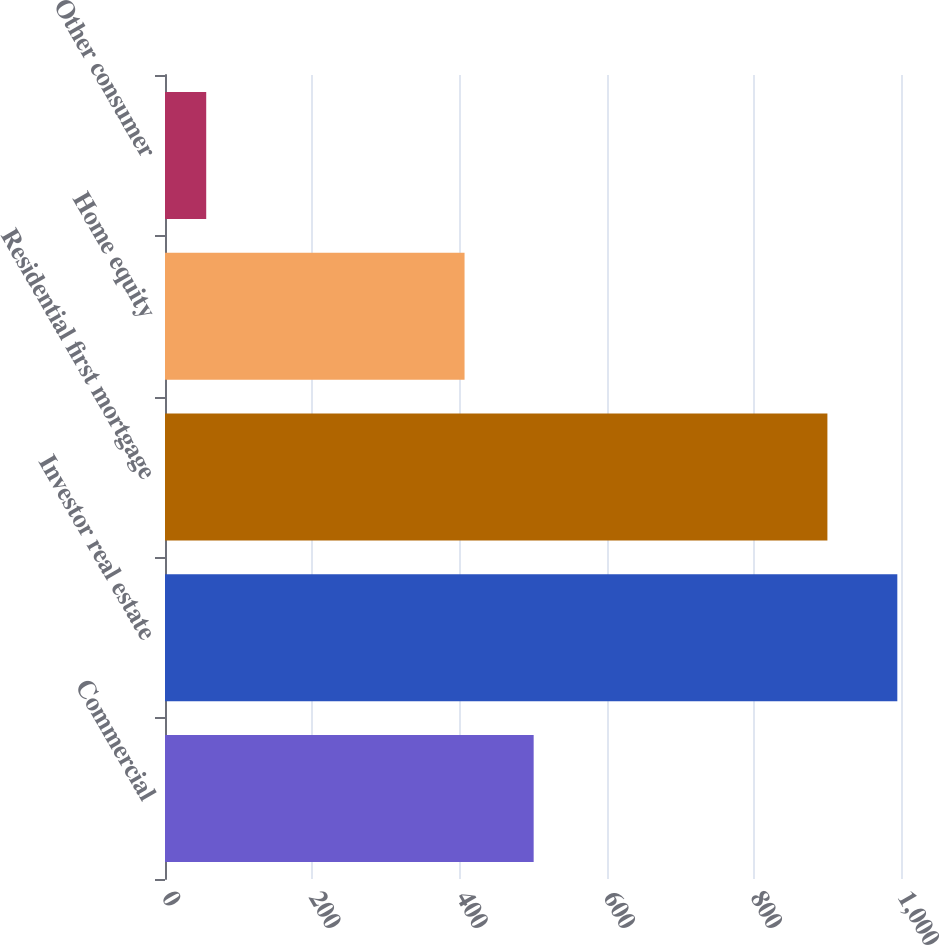Convert chart. <chart><loc_0><loc_0><loc_500><loc_500><bar_chart><fcel>Commercial<fcel>Investor real estate<fcel>Residential first mortgage<fcel>Home equity<fcel>Other consumer<nl><fcel>500.9<fcel>995<fcel>900<fcel>407<fcel>56<nl></chart> 